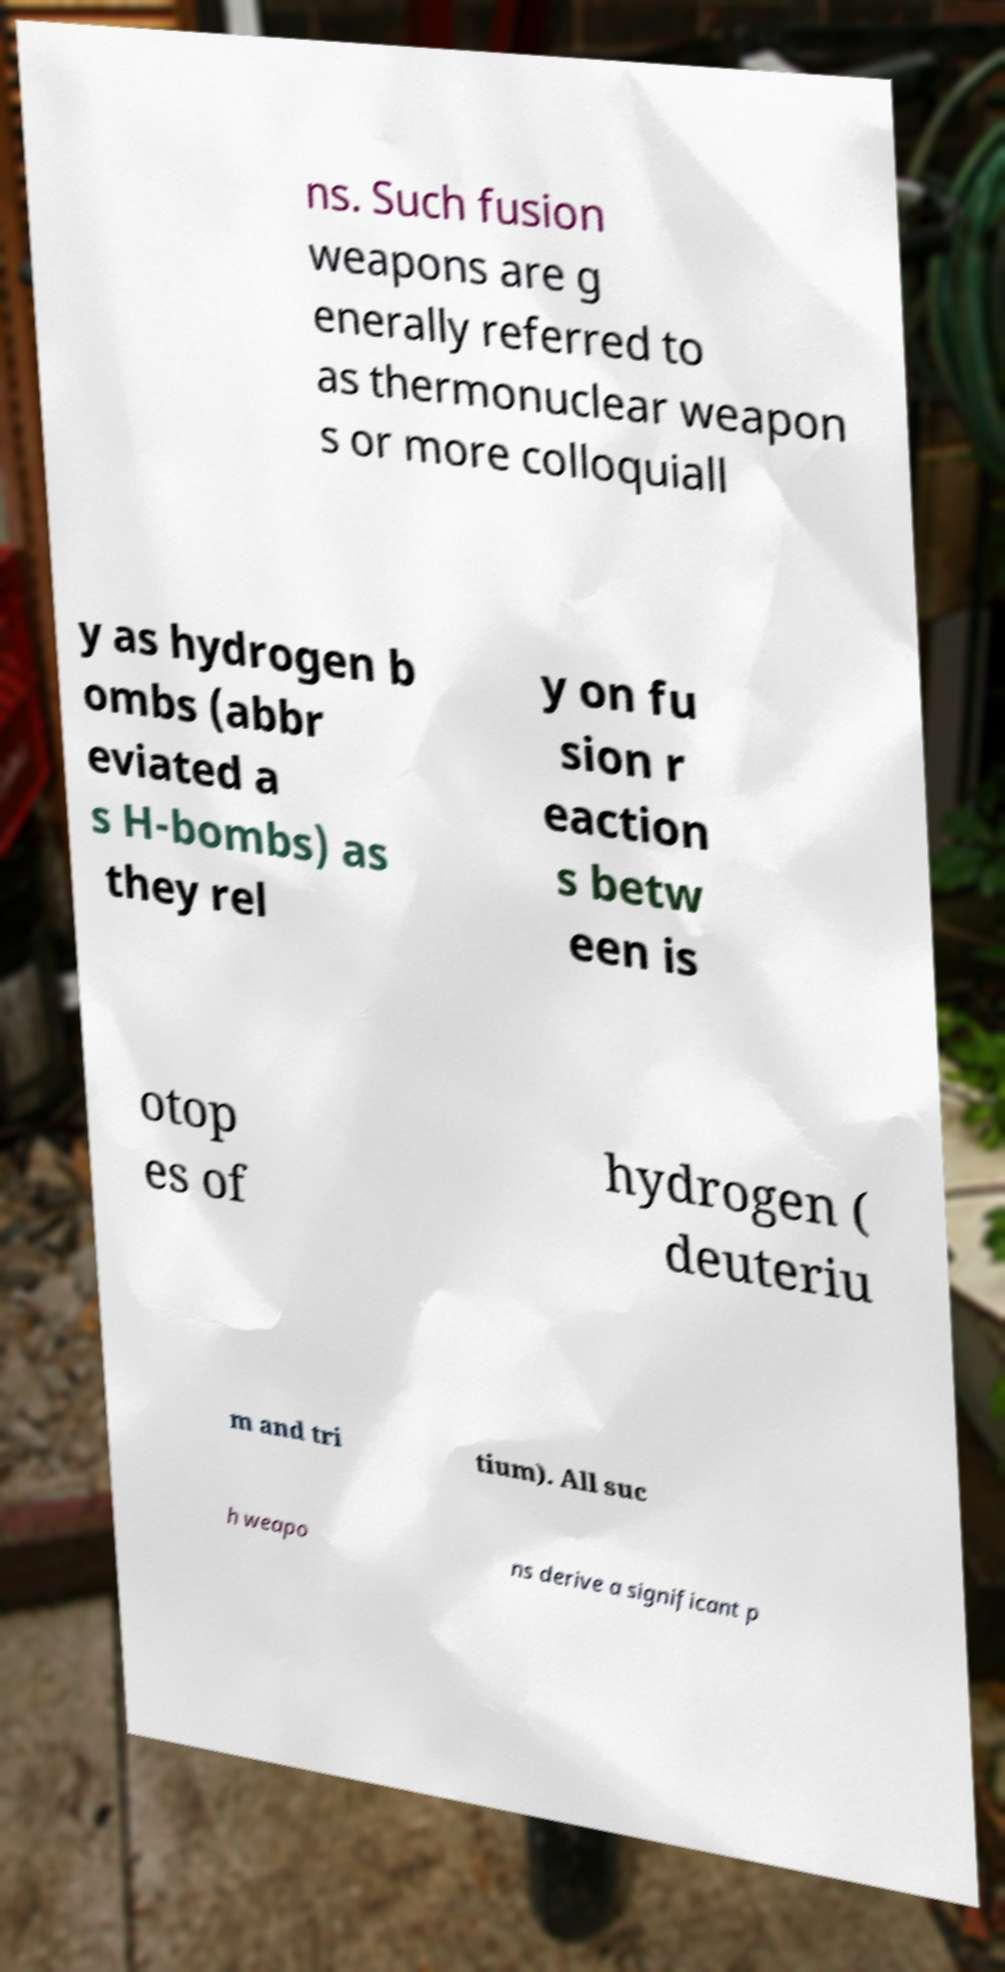Please read and relay the text visible in this image. What does it say? ns. Such fusion weapons are g enerally referred to as thermonuclear weapon s or more colloquiall y as hydrogen b ombs (abbr eviated a s H-bombs) as they rel y on fu sion r eaction s betw een is otop es of hydrogen ( deuteriu m and tri tium). All suc h weapo ns derive a significant p 